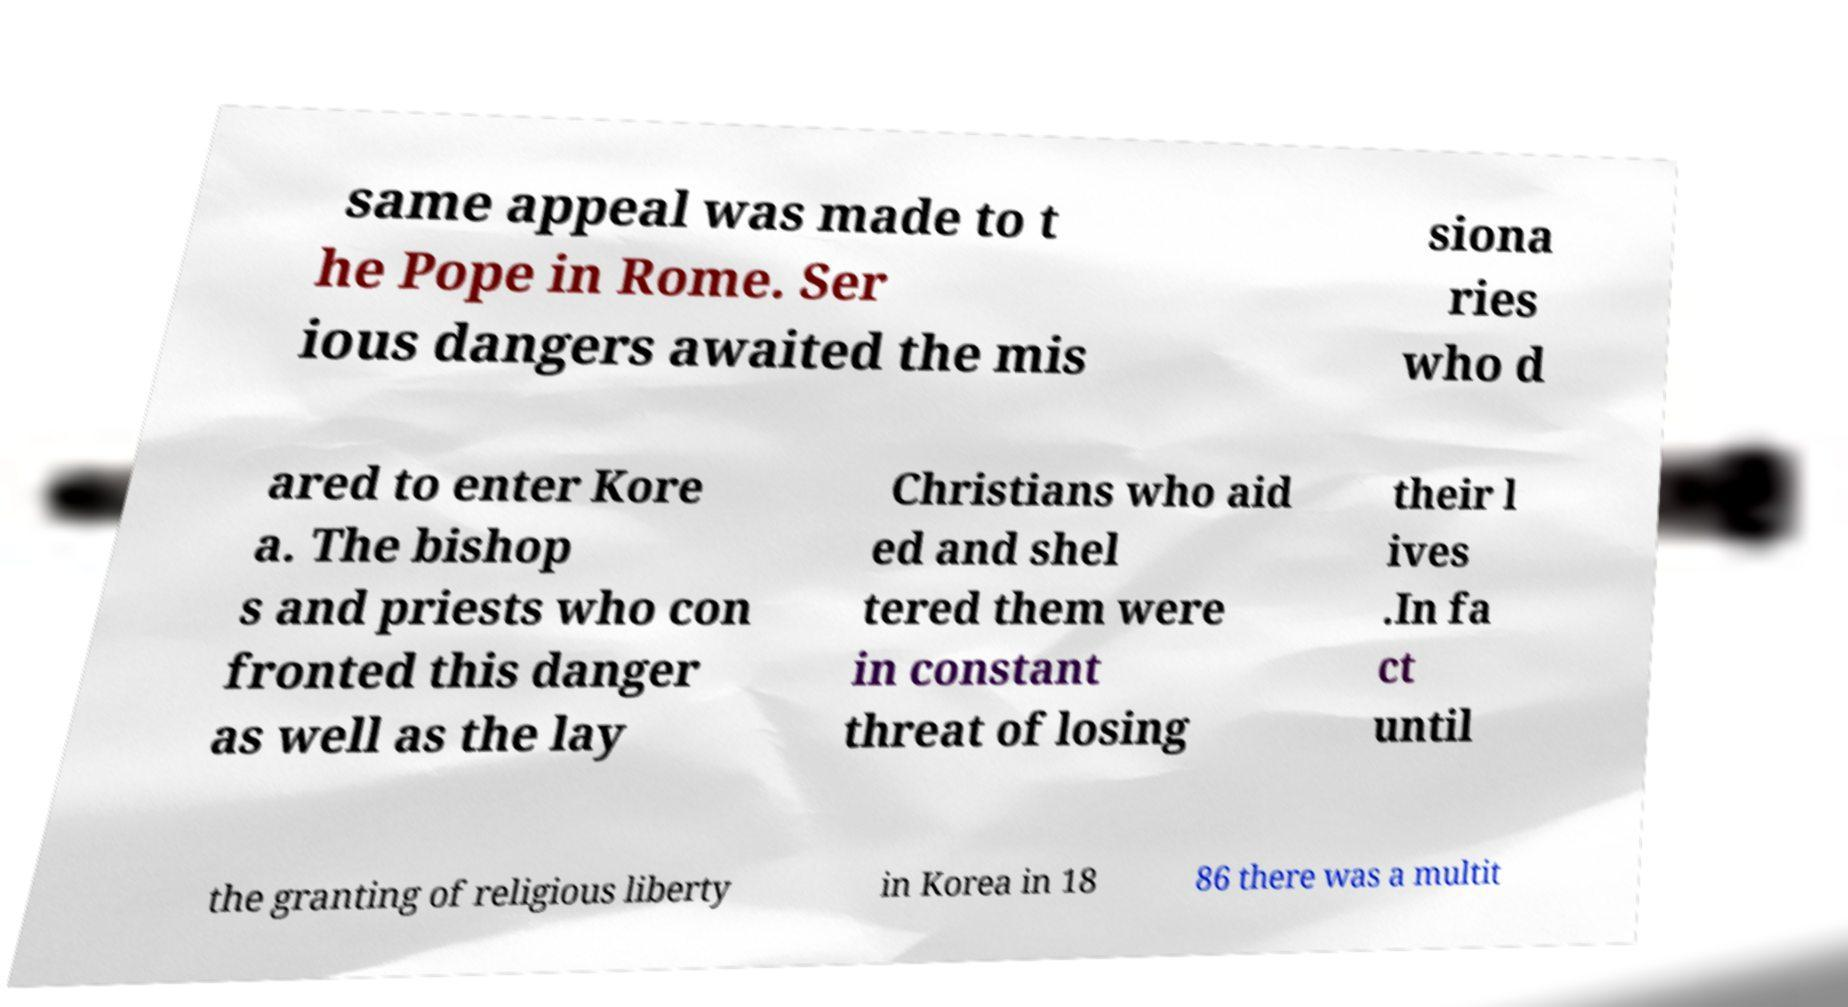There's text embedded in this image that I need extracted. Can you transcribe it verbatim? same appeal was made to t he Pope in Rome. Ser ious dangers awaited the mis siona ries who d ared to enter Kore a. The bishop s and priests who con fronted this danger as well as the lay Christians who aid ed and shel tered them were in constant threat of losing their l ives .In fa ct until the granting of religious liberty in Korea in 18 86 there was a multit 